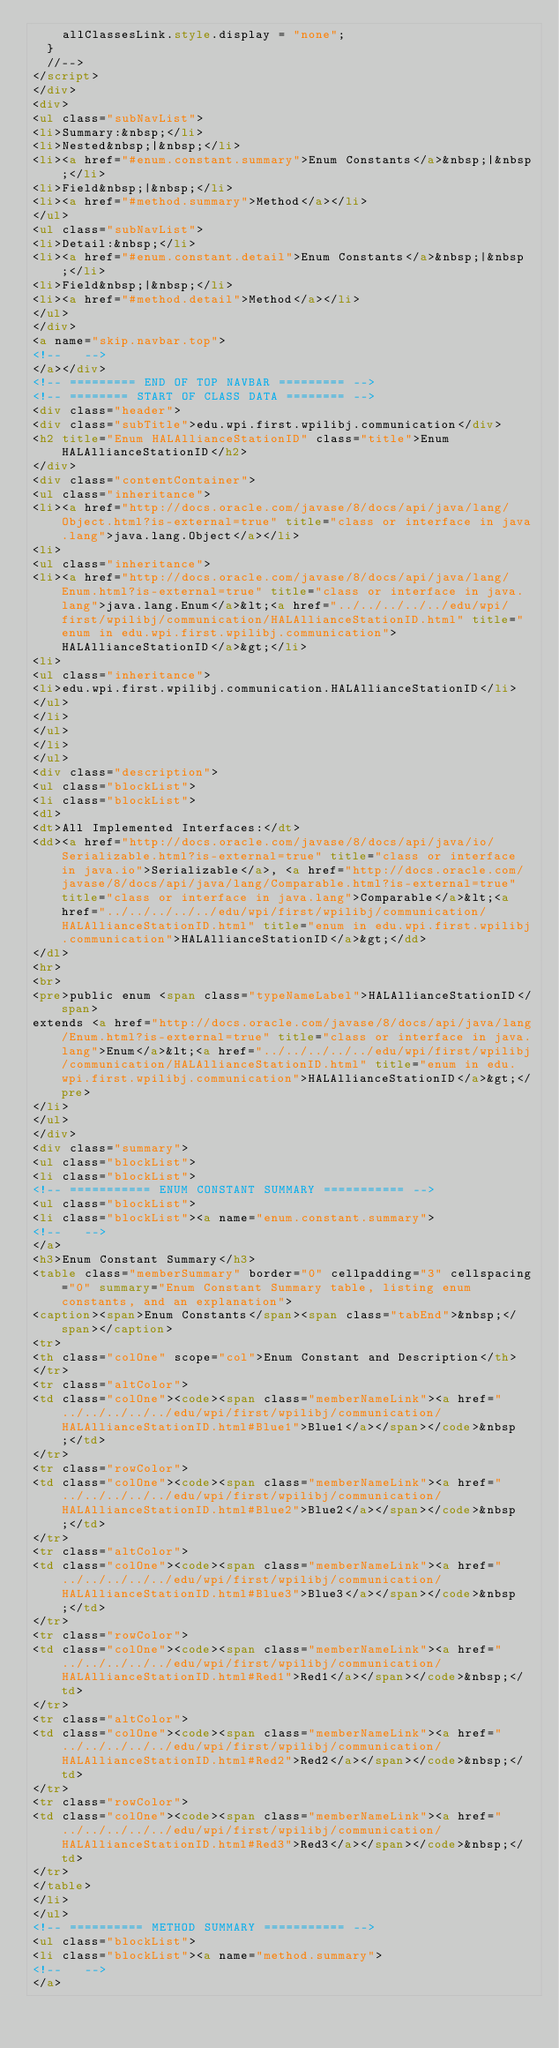Convert code to text. <code><loc_0><loc_0><loc_500><loc_500><_HTML_>    allClassesLink.style.display = "none";
  }
  //-->
</script>
</div>
<div>
<ul class="subNavList">
<li>Summary:&nbsp;</li>
<li>Nested&nbsp;|&nbsp;</li>
<li><a href="#enum.constant.summary">Enum Constants</a>&nbsp;|&nbsp;</li>
<li>Field&nbsp;|&nbsp;</li>
<li><a href="#method.summary">Method</a></li>
</ul>
<ul class="subNavList">
<li>Detail:&nbsp;</li>
<li><a href="#enum.constant.detail">Enum Constants</a>&nbsp;|&nbsp;</li>
<li>Field&nbsp;|&nbsp;</li>
<li><a href="#method.detail">Method</a></li>
</ul>
</div>
<a name="skip.navbar.top">
<!--   -->
</a></div>
<!-- ========= END OF TOP NAVBAR ========= -->
<!-- ======== START OF CLASS DATA ======== -->
<div class="header">
<div class="subTitle">edu.wpi.first.wpilibj.communication</div>
<h2 title="Enum HALAllianceStationID" class="title">Enum HALAllianceStationID</h2>
</div>
<div class="contentContainer">
<ul class="inheritance">
<li><a href="http://docs.oracle.com/javase/8/docs/api/java/lang/Object.html?is-external=true" title="class or interface in java.lang">java.lang.Object</a></li>
<li>
<ul class="inheritance">
<li><a href="http://docs.oracle.com/javase/8/docs/api/java/lang/Enum.html?is-external=true" title="class or interface in java.lang">java.lang.Enum</a>&lt;<a href="../../../../../edu/wpi/first/wpilibj/communication/HALAllianceStationID.html" title="enum in edu.wpi.first.wpilibj.communication">HALAllianceStationID</a>&gt;</li>
<li>
<ul class="inheritance">
<li>edu.wpi.first.wpilibj.communication.HALAllianceStationID</li>
</ul>
</li>
</ul>
</li>
</ul>
<div class="description">
<ul class="blockList">
<li class="blockList">
<dl>
<dt>All Implemented Interfaces:</dt>
<dd><a href="http://docs.oracle.com/javase/8/docs/api/java/io/Serializable.html?is-external=true" title="class or interface in java.io">Serializable</a>, <a href="http://docs.oracle.com/javase/8/docs/api/java/lang/Comparable.html?is-external=true" title="class or interface in java.lang">Comparable</a>&lt;<a href="../../../../../edu/wpi/first/wpilibj/communication/HALAllianceStationID.html" title="enum in edu.wpi.first.wpilibj.communication">HALAllianceStationID</a>&gt;</dd>
</dl>
<hr>
<br>
<pre>public enum <span class="typeNameLabel">HALAllianceStationID</span>
extends <a href="http://docs.oracle.com/javase/8/docs/api/java/lang/Enum.html?is-external=true" title="class or interface in java.lang">Enum</a>&lt;<a href="../../../../../edu/wpi/first/wpilibj/communication/HALAllianceStationID.html" title="enum in edu.wpi.first.wpilibj.communication">HALAllianceStationID</a>&gt;</pre>
</li>
</ul>
</div>
<div class="summary">
<ul class="blockList">
<li class="blockList">
<!-- =========== ENUM CONSTANT SUMMARY =========== -->
<ul class="blockList">
<li class="blockList"><a name="enum.constant.summary">
<!--   -->
</a>
<h3>Enum Constant Summary</h3>
<table class="memberSummary" border="0" cellpadding="3" cellspacing="0" summary="Enum Constant Summary table, listing enum constants, and an explanation">
<caption><span>Enum Constants</span><span class="tabEnd">&nbsp;</span></caption>
<tr>
<th class="colOne" scope="col">Enum Constant and Description</th>
</tr>
<tr class="altColor">
<td class="colOne"><code><span class="memberNameLink"><a href="../../../../../edu/wpi/first/wpilibj/communication/HALAllianceStationID.html#Blue1">Blue1</a></span></code>&nbsp;</td>
</tr>
<tr class="rowColor">
<td class="colOne"><code><span class="memberNameLink"><a href="../../../../../edu/wpi/first/wpilibj/communication/HALAllianceStationID.html#Blue2">Blue2</a></span></code>&nbsp;</td>
</tr>
<tr class="altColor">
<td class="colOne"><code><span class="memberNameLink"><a href="../../../../../edu/wpi/first/wpilibj/communication/HALAllianceStationID.html#Blue3">Blue3</a></span></code>&nbsp;</td>
</tr>
<tr class="rowColor">
<td class="colOne"><code><span class="memberNameLink"><a href="../../../../../edu/wpi/first/wpilibj/communication/HALAllianceStationID.html#Red1">Red1</a></span></code>&nbsp;</td>
</tr>
<tr class="altColor">
<td class="colOne"><code><span class="memberNameLink"><a href="../../../../../edu/wpi/first/wpilibj/communication/HALAllianceStationID.html#Red2">Red2</a></span></code>&nbsp;</td>
</tr>
<tr class="rowColor">
<td class="colOne"><code><span class="memberNameLink"><a href="../../../../../edu/wpi/first/wpilibj/communication/HALAllianceStationID.html#Red3">Red3</a></span></code>&nbsp;</td>
</tr>
</table>
</li>
</ul>
<!-- ========== METHOD SUMMARY =========== -->
<ul class="blockList">
<li class="blockList"><a name="method.summary">
<!--   -->
</a></code> 